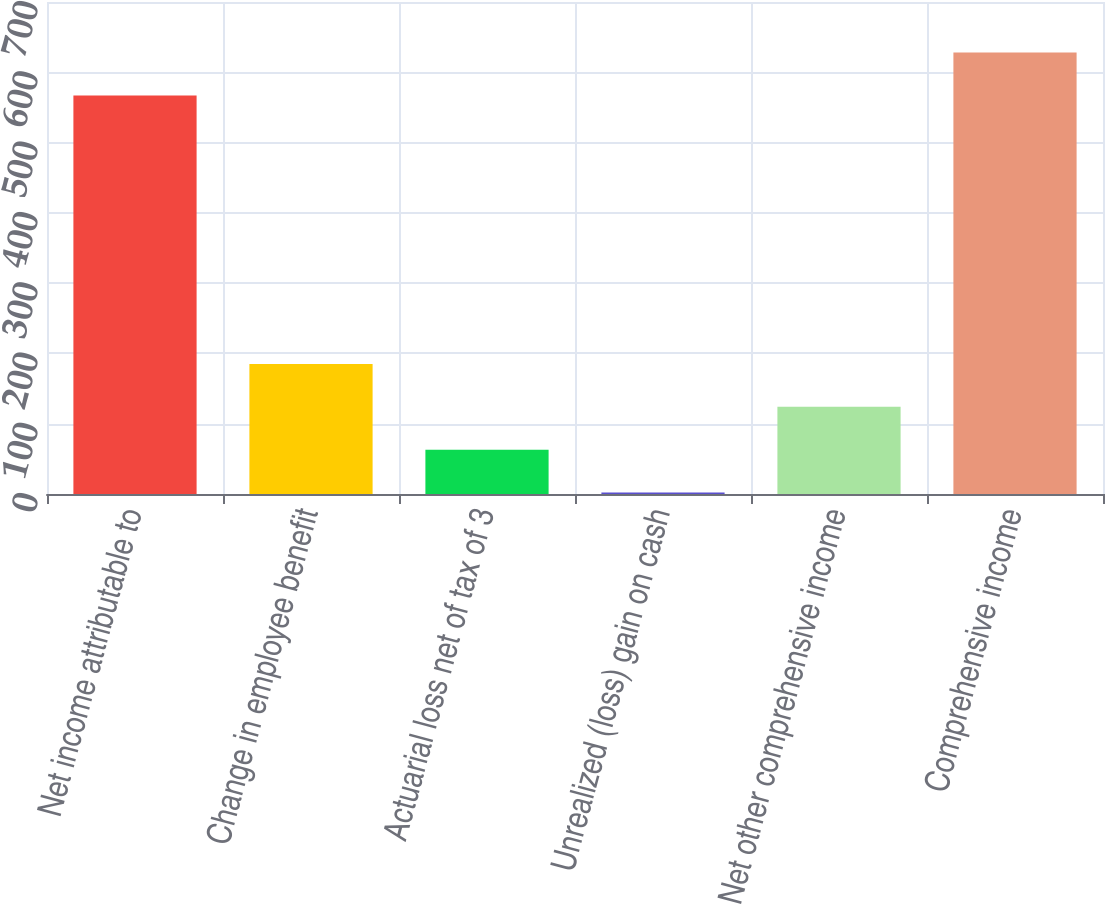Convert chart. <chart><loc_0><loc_0><loc_500><loc_500><bar_chart><fcel>Net income attributable to<fcel>Change in employee benefit<fcel>Actuarial loss net of tax of 3<fcel>Unrealized (loss) gain on cash<fcel>Net other comprehensive income<fcel>Comprehensive income<nl><fcel>567<fcel>185<fcel>63<fcel>2<fcel>124<fcel>628<nl></chart> 